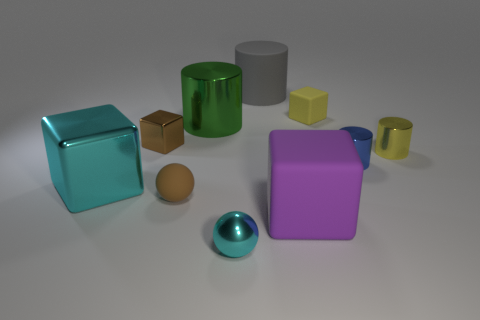Is the material of the tiny object behind the brown metal object the same as the big cube that is to the right of the large cyan shiny block?
Your answer should be very brief. Yes. How many rubber things are either big cubes or yellow cylinders?
Make the answer very short. 1. What material is the yellow object behind the yellow cylinder in front of the tiny matte thing to the right of the rubber cylinder made of?
Ensure brevity in your answer.  Rubber. There is a cyan metallic thing in front of the big cyan metal block; is its shape the same as the cyan metallic thing behind the small cyan ball?
Give a very brief answer. No. What is the color of the small matte object to the left of the big purple object that is in front of the green object?
Ensure brevity in your answer.  Brown. How many cylinders are either tiny yellow things or small blue objects?
Keep it short and to the point. 2. There is a small cube that is to the left of the rubber block that is on the left side of the yellow block; what number of green metal cylinders are in front of it?
Your response must be concise. 0. There is a thing that is the same color as the big metallic block; what is its size?
Ensure brevity in your answer.  Small. Is there a tiny purple cube that has the same material as the large gray thing?
Give a very brief answer. No. Do the gray cylinder and the brown sphere have the same material?
Provide a short and direct response. Yes. 